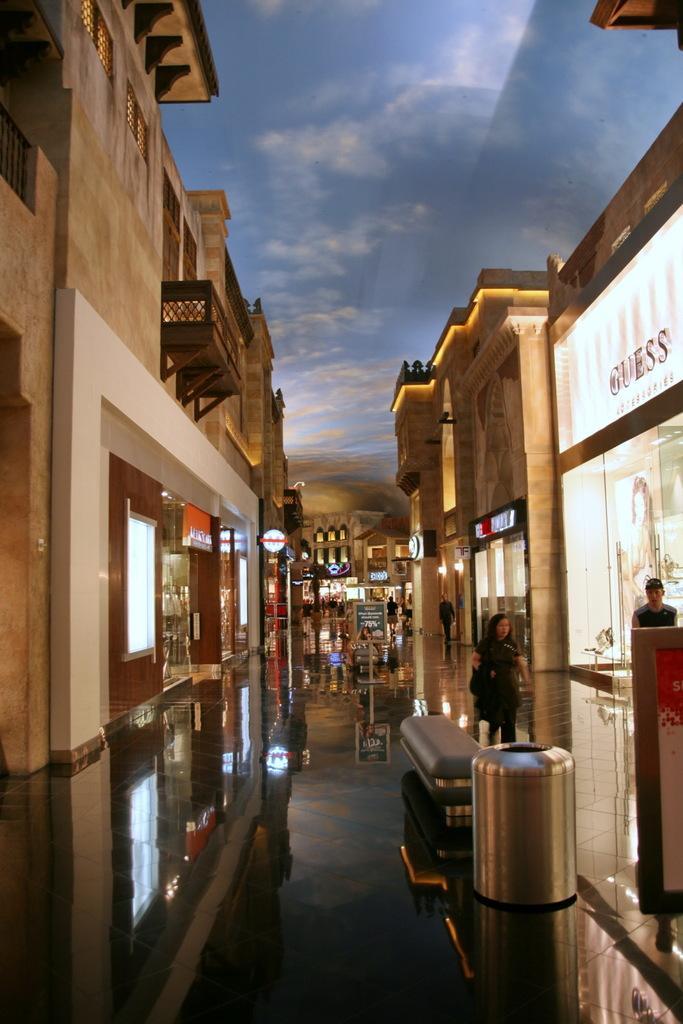Describe this image in one or two sentences. In this image we can see some few stores. A lady is walking on the footpath and a man is standing near a store. 